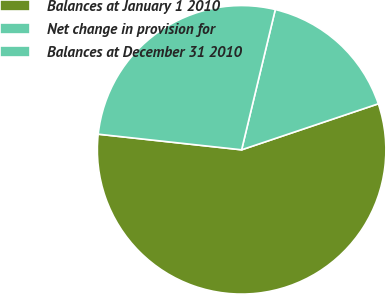Convert chart. <chart><loc_0><loc_0><loc_500><loc_500><pie_chart><fcel>Balances at January 1 2010<fcel>Net change in provision for<fcel>Balances at December 31 2010<nl><fcel>56.89%<fcel>16.08%<fcel>27.02%<nl></chart> 